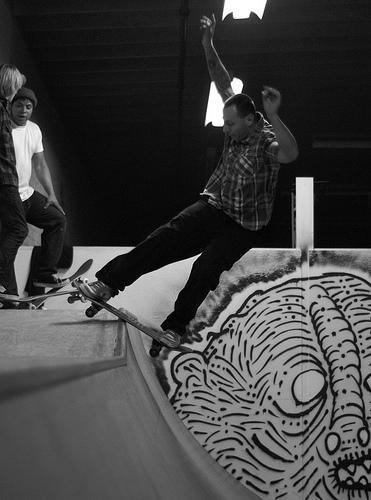How many people can be seen?
Give a very brief answer. 3. How many giraffe are on the grass?
Give a very brief answer. 0. 